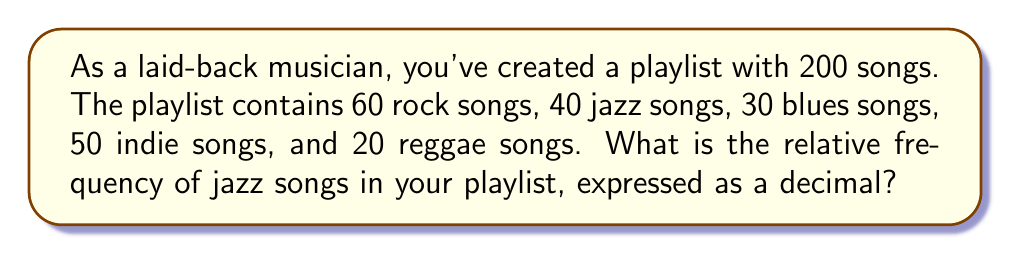Can you answer this question? To find the relative frequency of jazz songs in the playlist, we need to follow these steps:

1. Identify the total number of songs in the playlist:
   $N_{total} = 200$

2. Identify the number of jazz songs:
   $N_{jazz} = 40$

3. Calculate the relative frequency using the formula:
   $$ \text{Relative Frequency} = \frac{\text{Number of occurrences}}{\text{Total number of items}} $$

4. Plug in the values:
   $$ \text{Relative Frequency of Jazz} = \frac{N_{jazz}}{N_{total}} = \frac{40}{200} $$

5. Simplify the fraction:
   $$ \frac{40}{200} = \frac{1}{5} = 0.2 $$

Therefore, the relative frequency of jazz songs in your playlist is 0.2 or 20% when expressed as a percentage.
Answer: 0.2 